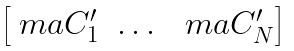<formula> <loc_0><loc_0><loc_500><loc_500>\begin{bmatrix} \ m a { C } _ { 1 } ^ { \prime } & \dots & \ m a { C } _ { N } ^ { \prime } \end{bmatrix}</formula> 